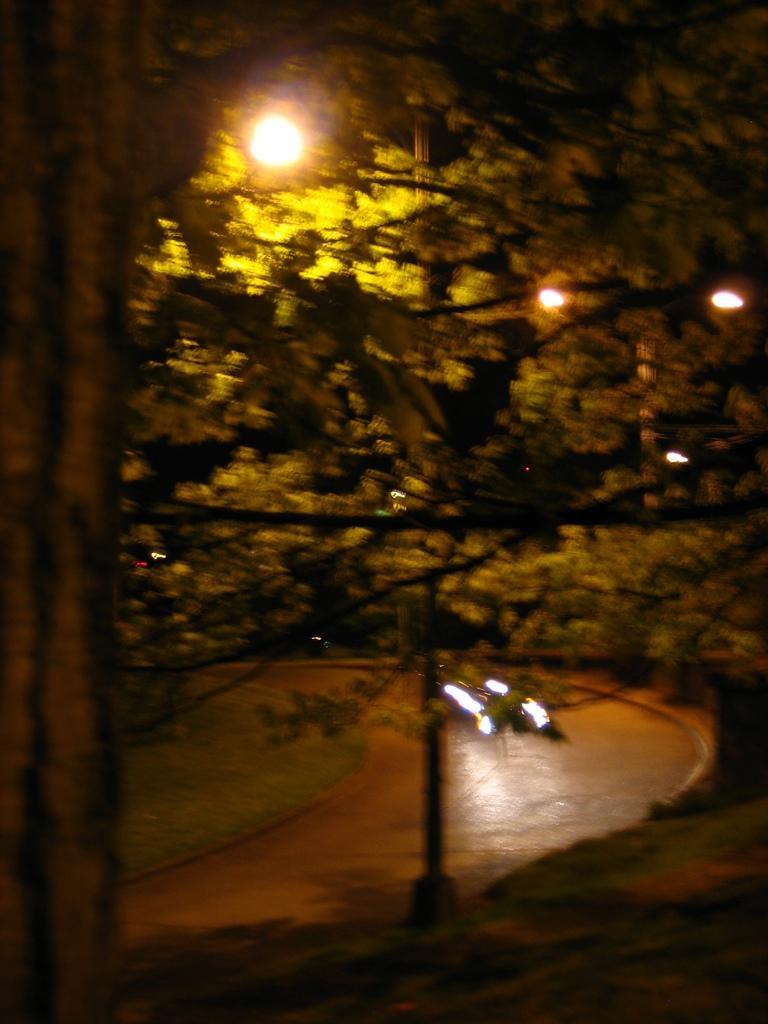Can you describe this image briefly? In this image, we can see vehicles on the road and in the background, there are trees and lights. 